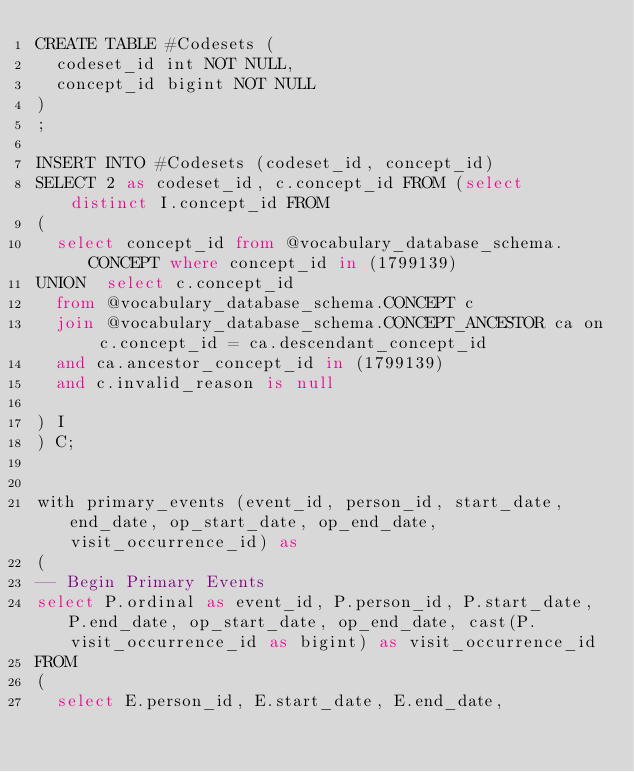<code> <loc_0><loc_0><loc_500><loc_500><_SQL_>CREATE TABLE #Codesets (
  codeset_id int NOT NULL,
  concept_id bigint NOT NULL
)
;

INSERT INTO #Codesets (codeset_id, concept_id)
SELECT 2 as codeset_id, c.concept_id FROM (select distinct I.concept_id FROM
( 
  select concept_id from @vocabulary_database_schema.CONCEPT where concept_id in (1799139)
UNION  select c.concept_id
  from @vocabulary_database_schema.CONCEPT c
  join @vocabulary_database_schema.CONCEPT_ANCESTOR ca on c.concept_id = ca.descendant_concept_id
  and ca.ancestor_concept_id in (1799139)
  and c.invalid_reason is null

) I
) C;


with primary_events (event_id, person_id, start_date, end_date, op_start_date, op_end_date, visit_occurrence_id) as
(
-- Begin Primary Events
select P.ordinal as event_id, P.person_id, P.start_date, P.end_date, op_start_date, op_end_date, cast(P.visit_occurrence_id as bigint) as visit_occurrence_id
FROM
(
  select E.person_id, E.start_date, E.end_date,</code> 